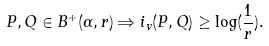<formula> <loc_0><loc_0><loc_500><loc_500>P , Q \in B ^ { + } ( \alpha , r ) \Rightarrow i _ { v } ( P , Q ) \geq \log ( \frac { 1 } { r } ) .</formula> 